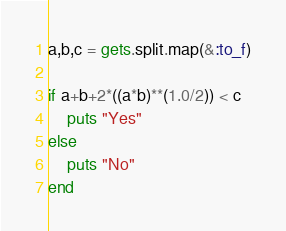<code> <loc_0><loc_0><loc_500><loc_500><_Ruby_>a,b,c = gets.split.map(&:to_f)

if a+b+2*((a*b)**(1.0/2)) < c
    puts "Yes"
else
    puts "No"
end</code> 